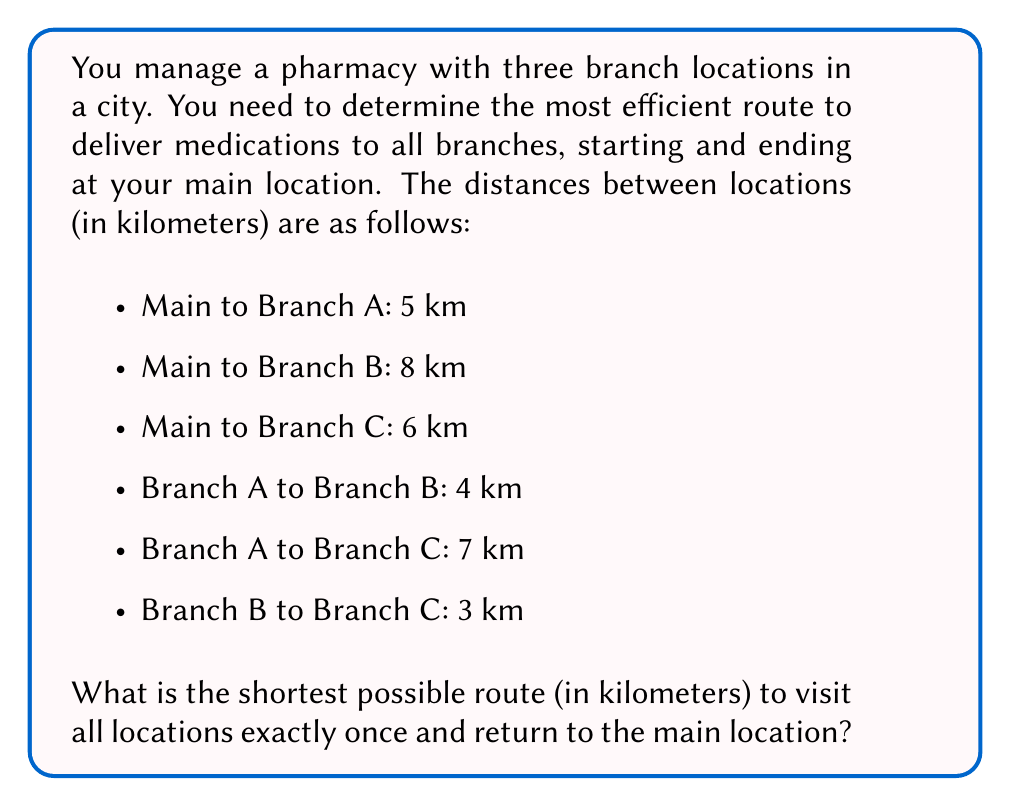Help me with this question. This problem is an instance of the Traveling Salesman Problem (TSP). To solve it, we'll use the following approach:

1) List all possible routes:
   There are 3! = 6 possible routes (excluding the start and end at the main location):
   
   a) Main → A → B → C → Main
   b) Main → A → C → B → Main
   c) Main → B → A → C → Main
   d) Main → B → C → A → Main
   e) Main → C → A → B → Main
   f) Main → C → B → A → Main

2) Calculate the total distance for each route:

   a) Main → A → B → C → Main
      $5 + 4 + 3 + 6 = 18$ km
   
   b) Main → A → C → B → Main
      $5 + 7 + 3 + 8 = 23$ km
   
   c) Main → B → A → C → Main
      $8 + 4 + 7 + 6 = 25$ km
   
   d) Main → B → C → A → Main
      $8 + 3 + 7 + 5 = 23$ km
   
   e) Main → C → A → B → Main
      $6 + 7 + 4 + 8 = 25$ km
   
   f) Main → C → B → A → Main
      $6 + 3 + 4 + 5 = 18$ km

3) Identify the shortest route(s):
   The shortest routes are (a) and (f), both with a total distance of 18 km.

Therefore, the most efficient delivery route is either:
Main → A → B → C → Main
or
Main → C → B → A → Main
Answer: The shortest possible route is 18 km. 